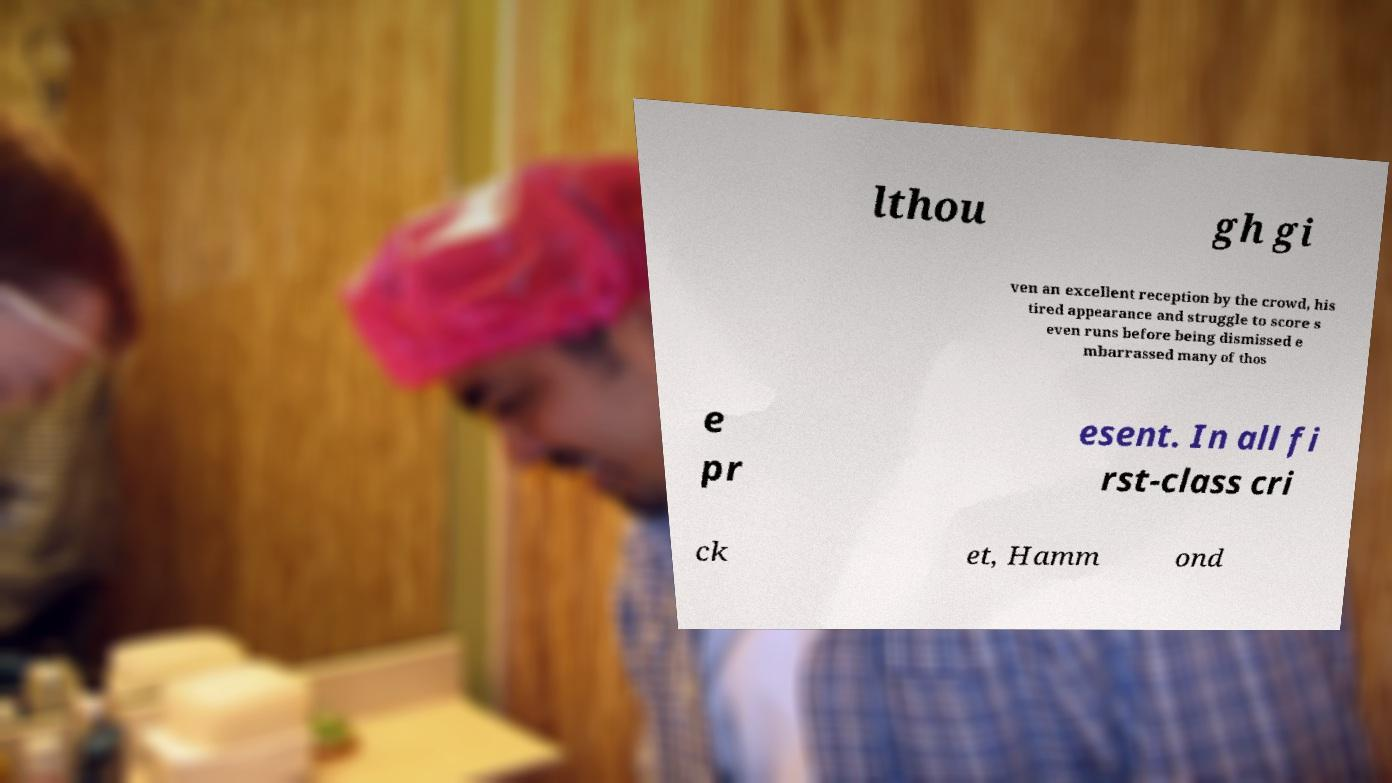Can you read and provide the text displayed in the image?This photo seems to have some interesting text. Can you extract and type it out for me? lthou gh gi ven an excellent reception by the crowd, his tired appearance and struggle to score s even runs before being dismissed e mbarrassed many of thos e pr esent. In all fi rst-class cri ck et, Hamm ond 